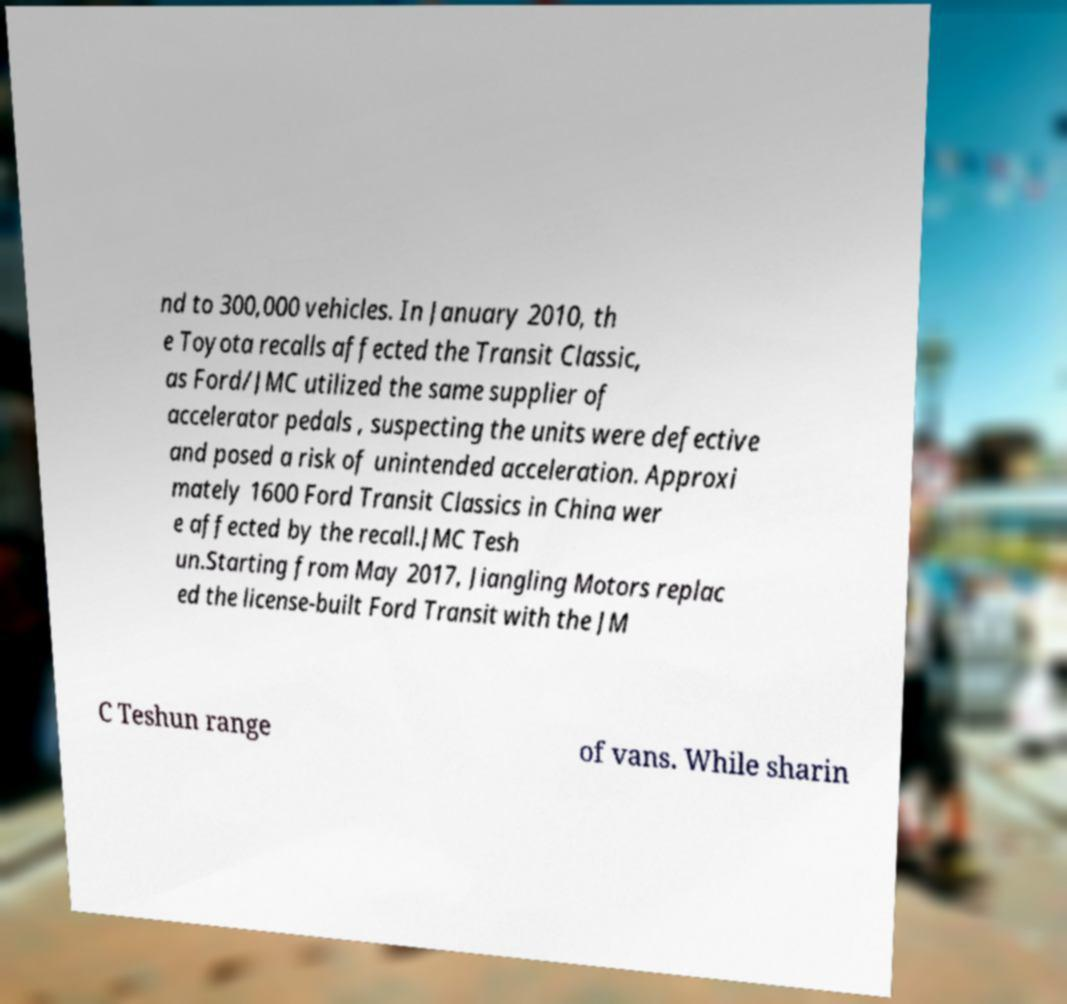Can you read and provide the text displayed in the image?This photo seems to have some interesting text. Can you extract and type it out for me? nd to 300,000 vehicles. In January 2010, th e Toyota recalls affected the Transit Classic, as Ford/JMC utilized the same supplier of accelerator pedals , suspecting the units were defective and posed a risk of unintended acceleration. Approxi mately 1600 Ford Transit Classics in China wer e affected by the recall.JMC Tesh un.Starting from May 2017, Jiangling Motors replac ed the license-built Ford Transit with the JM C Teshun range of vans. While sharin 